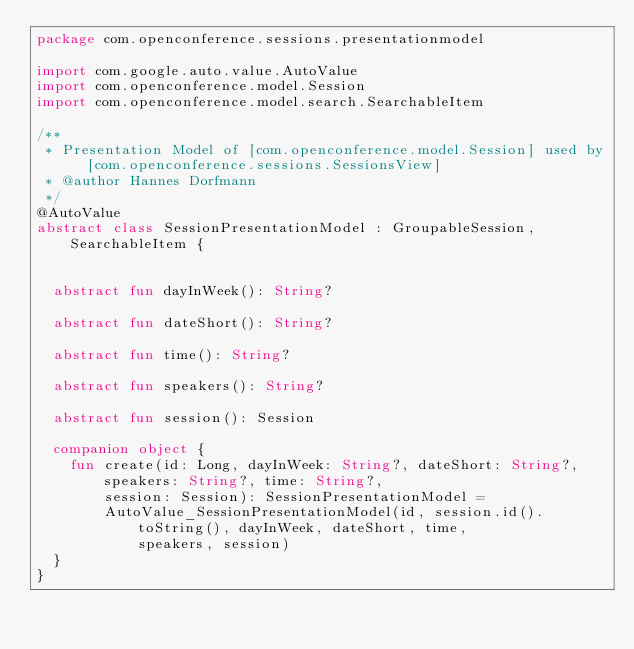Convert code to text. <code><loc_0><loc_0><loc_500><loc_500><_Kotlin_>package com.openconference.sessions.presentationmodel

import com.google.auto.value.AutoValue
import com.openconference.model.Session
import com.openconference.model.search.SearchableItem

/**
 * Presentation Model of [com.openconference.model.Session] used by [com.openconference.sessions.SessionsView]
 * @author Hannes Dorfmann
 */
@AutoValue
abstract class SessionPresentationModel : GroupableSession, SearchableItem {


  abstract fun dayInWeek(): String?

  abstract fun dateShort(): String?

  abstract fun time(): String?

  abstract fun speakers(): String?

  abstract fun session(): Session

  companion object {
    fun create(id: Long, dayInWeek: String?, dateShort: String?, speakers: String?, time: String?,
        session: Session): SessionPresentationModel =
        AutoValue_SessionPresentationModel(id, session.id().toString(), dayInWeek, dateShort, time,
            speakers, session)
  }
}</code> 